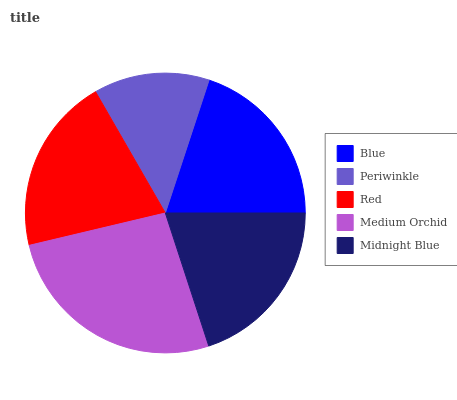Is Periwinkle the minimum?
Answer yes or no. Yes. Is Medium Orchid the maximum?
Answer yes or no. Yes. Is Red the minimum?
Answer yes or no. No. Is Red the maximum?
Answer yes or no. No. Is Red greater than Periwinkle?
Answer yes or no. Yes. Is Periwinkle less than Red?
Answer yes or no. Yes. Is Periwinkle greater than Red?
Answer yes or no. No. Is Red less than Periwinkle?
Answer yes or no. No. Is Midnight Blue the high median?
Answer yes or no. Yes. Is Midnight Blue the low median?
Answer yes or no. Yes. Is Red the high median?
Answer yes or no. No. Is Blue the low median?
Answer yes or no. No. 